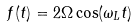Convert formula to latex. <formula><loc_0><loc_0><loc_500><loc_500>f ( t ) = 2 \Omega \cos ( \omega _ { L } t )</formula> 